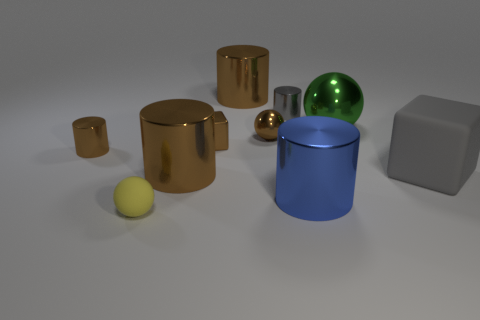Subtract all brown spheres. How many brown cylinders are left? 3 Subtract 1 cylinders. How many cylinders are left? 4 Subtract all blue cylinders. How many cylinders are left? 4 Subtract all tiny brown shiny cylinders. How many cylinders are left? 4 Subtract all yellow cylinders. Subtract all brown balls. How many cylinders are left? 5 Subtract all spheres. How many objects are left? 7 Subtract all small things. Subtract all tiny metallic blocks. How many objects are left? 4 Add 9 large blue metal cylinders. How many large blue metal cylinders are left? 10 Add 5 gray rubber blocks. How many gray rubber blocks exist? 6 Subtract 0 purple cylinders. How many objects are left? 10 